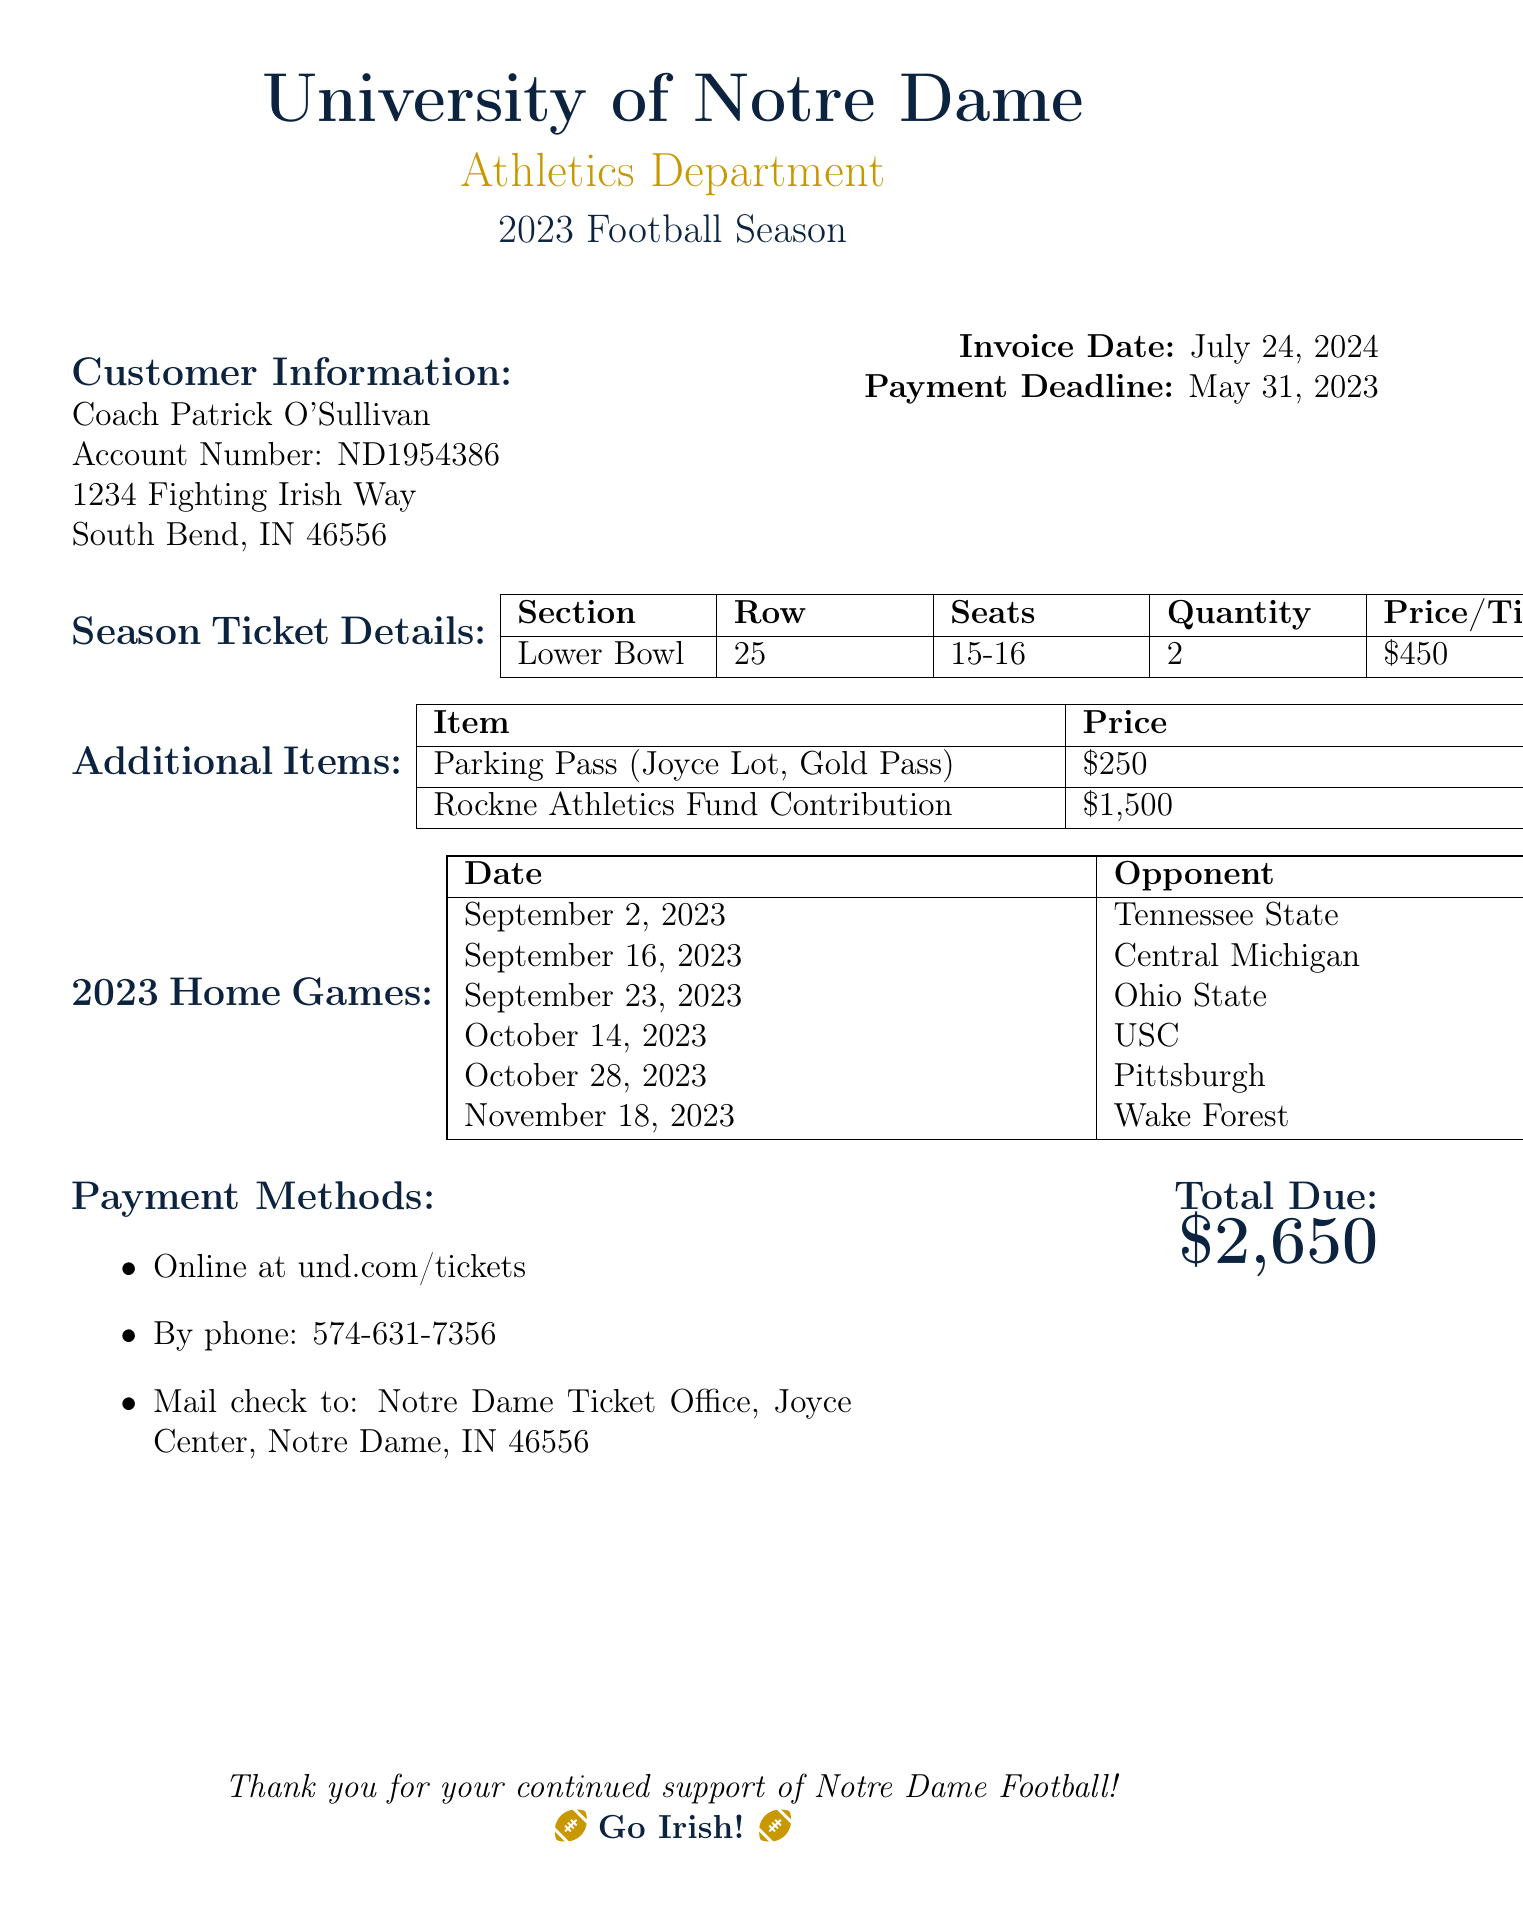What is the account number? The account number is listed under customer information in the document.
Answer: ND1954386 What is the payment deadline? The deadline for payment is mentioned in the header section of the invoice.
Answer: May 31, 2023 How many tickets were purchased? The number of tickets is indicated in the season ticket details table.
Answer: 2 What is the price of the parking pass? The price of the parking pass is listed in the additional items section.
Answer: $250 What is the total due amount? The total due amount is specified at the end of the invoice.
Answer: $2,650 What is the date of the game against USC? The game dates are listed in the home games section.
Answer: October 14, 2023 What is the total contribution to the Rockne Athletics Fund? The total contribution is indicated in the additional items section of the document.
Answer: $1,500 What section are the season tickets located in? The section for the tickets is provided in the season ticket details table.
Answer: Lower Bowl 